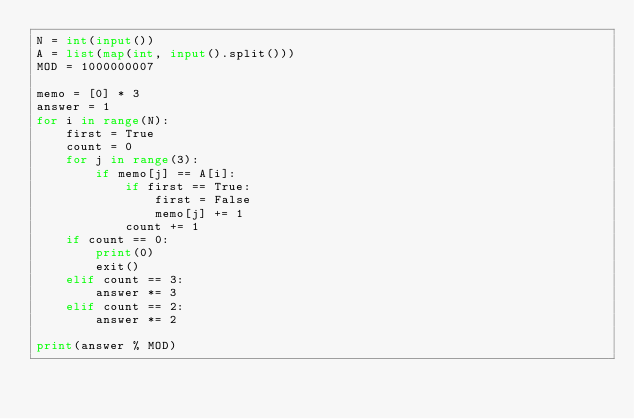Convert code to text. <code><loc_0><loc_0><loc_500><loc_500><_Python_>N = int(input())
A = list(map(int, input().split()))
MOD = 1000000007

memo = [0] * 3
answer = 1
for i in range(N):
    first = True
    count = 0
    for j in range(3):
        if memo[j] == A[i]:
            if first == True:
                first = False
                memo[j] += 1
            count += 1
    if count == 0:
        print(0)
        exit()
    elif count == 3:
        answer *= 3
    elif count == 2:
        answer *= 2

print(answer % MOD)</code> 